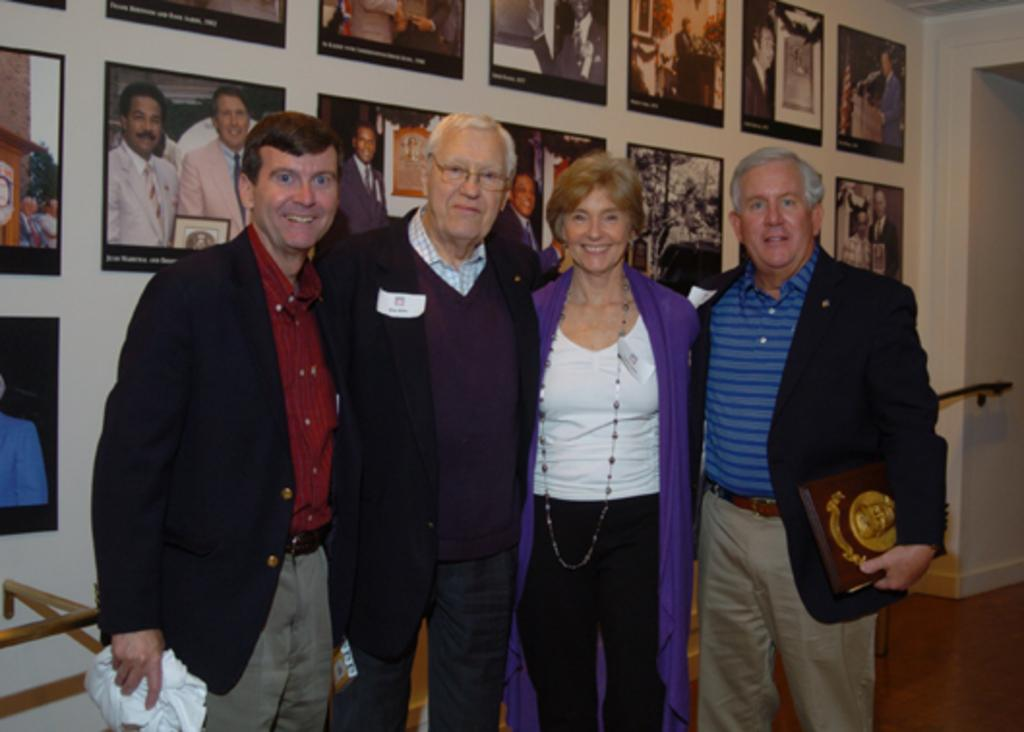What are the people in the image doing? The people are posing for a photo. What can be seen in the background of the image? There is a wall in the background of the image. What is on the wall in the image? The wall has photo frames on it. What type of patch is being offered to the people in the image? There is no patch or offer present in the image; it only shows people posing for a photo and a wall with photo frames. 